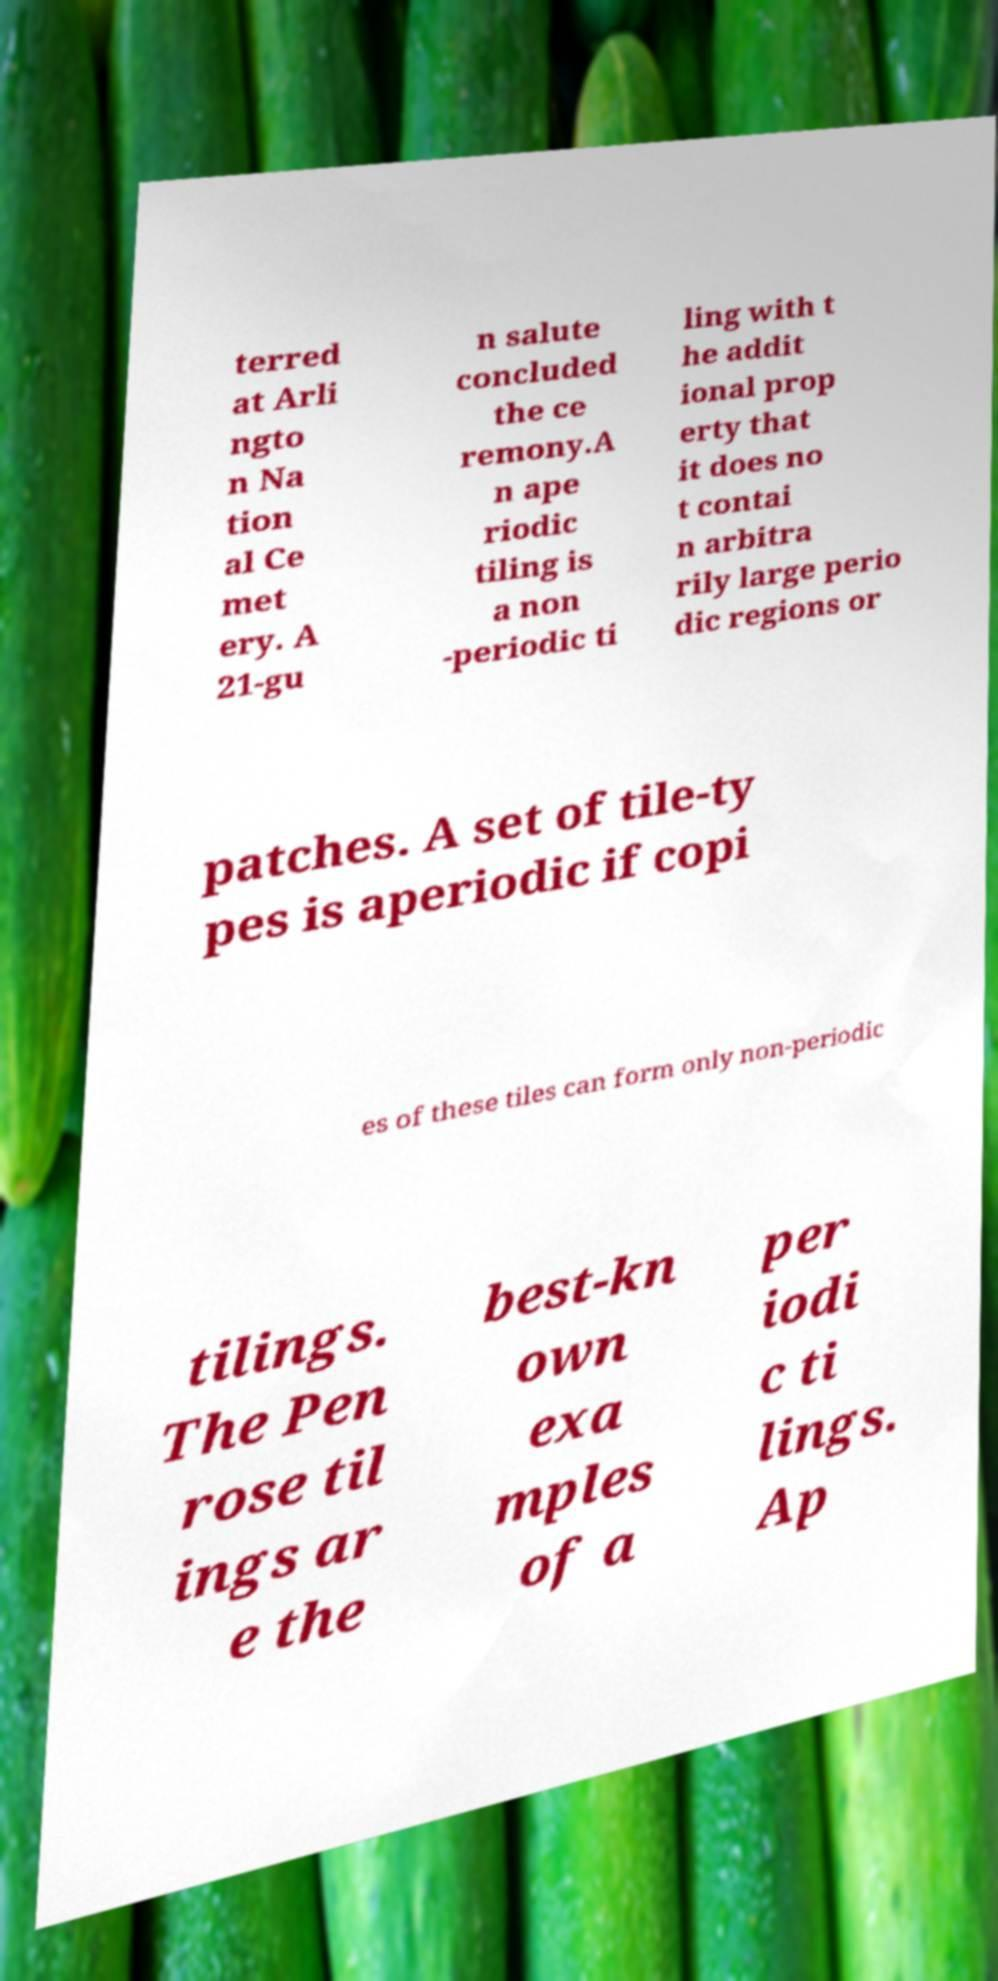Please identify and transcribe the text found in this image. terred at Arli ngto n Na tion al Ce met ery. A 21-gu n salute concluded the ce remony.A n ape riodic tiling is a non -periodic ti ling with t he addit ional prop erty that it does no t contai n arbitra rily large perio dic regions or patches. A set of tile-ty pes is aperiodic if copi es of these tiles can form only non-periodic tilings. The Pen rose til ings ar e the best-kn own exa mples of a per iodi c ti lings. Ap 